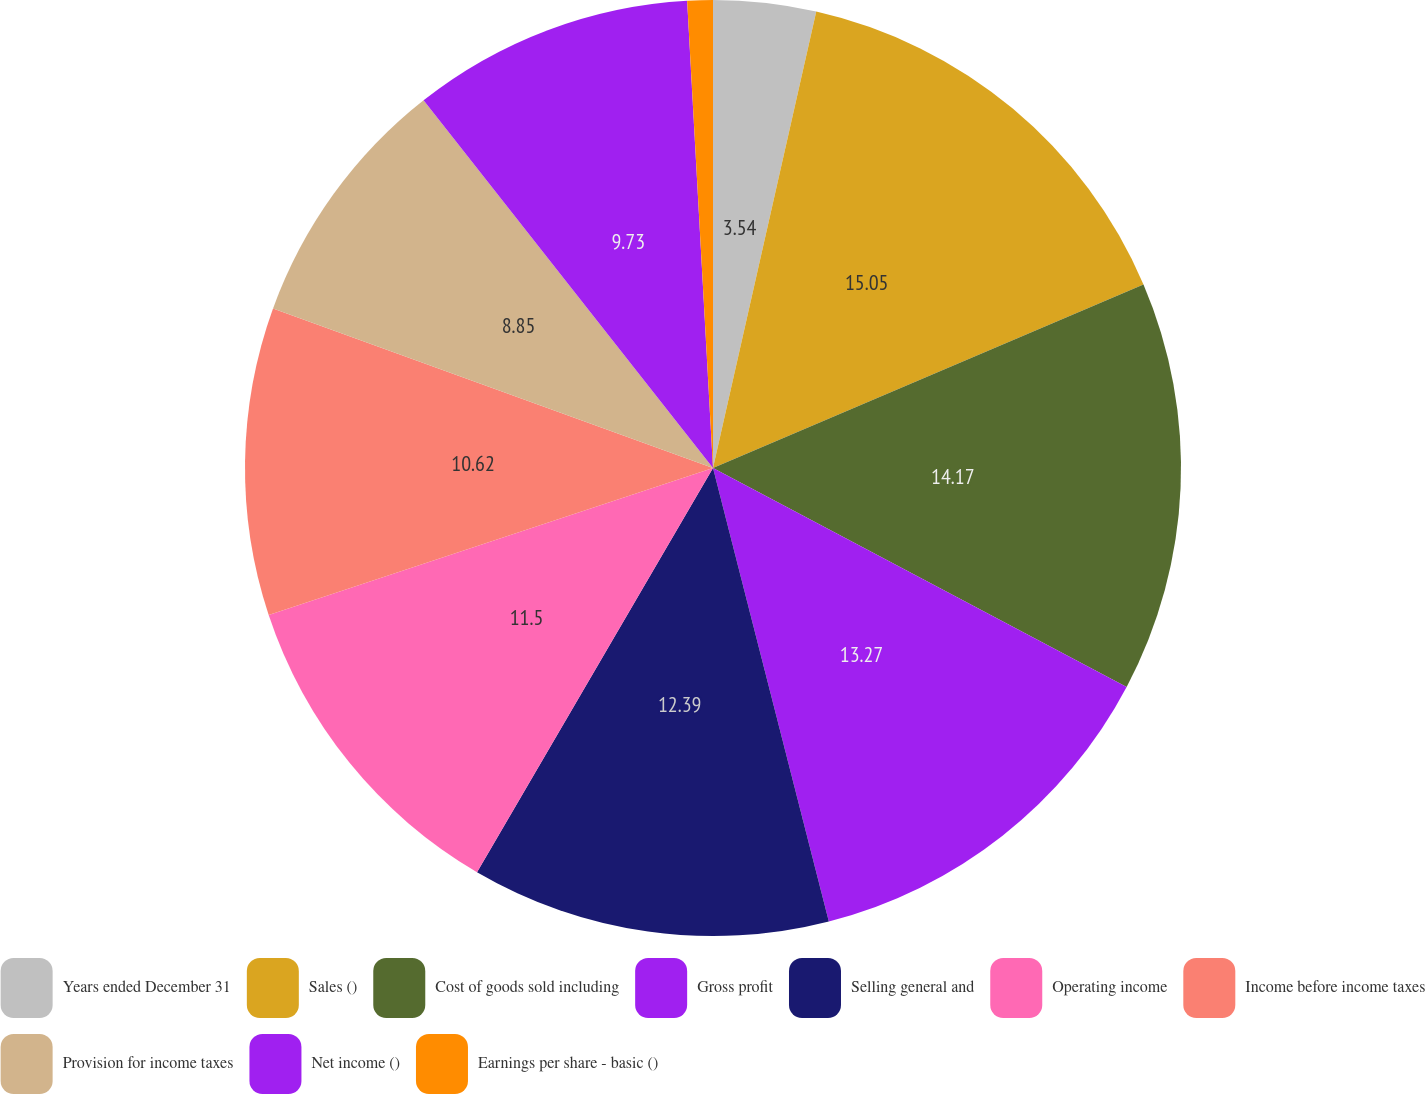<chart> <loc_0><loc_0><loc_500><loc_500><pie_chart><fcel>Years ended December 31<fcel>Sales ()<fcel>Cost of goods sold including<fcel>Gross profit<fcel>Selling general and<fcel>Operating income<fcel>Income before income taxes<fcel>Provision for income taxes<fcel>Net income ()<fcel>Earnings per share - basic ()<nl><fcel>3.54%<fcel>15.04%<fcel>14.16%<fcel>13.27%<fcel>12.39%<fcel>11.5%<fcel>10.62%<fcel>8.85%<fcel>9.73%<fcel>0.88%<nl></chart> 